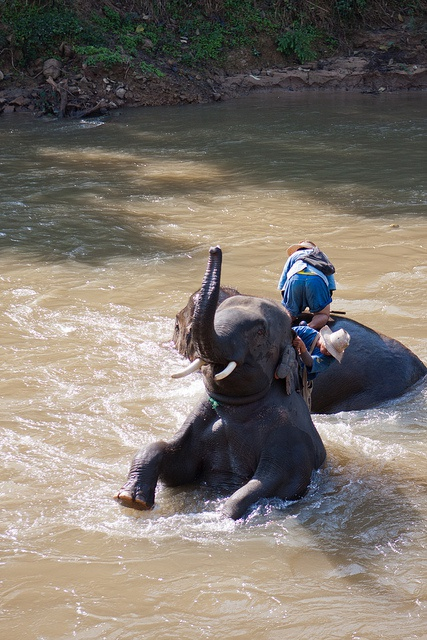Describe the objects in this image and their specific colors. I can see elephant in purple, black, darkgray, and gray tones, elephant in purple, black, navy, darkblue, and gray tones, people in purple, navy, blue, black, and white tones, people in purple, black, navy, darkgray, and lightgray tones, and backpack in purple, black, darkgray, gray, and navy tones in this image. 